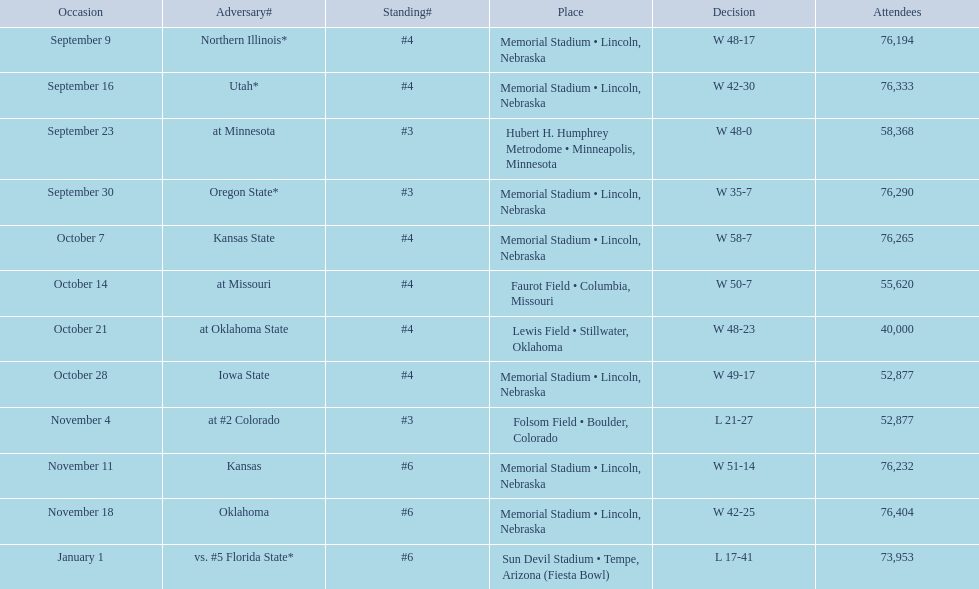What is the next site listed after lewis field? Memorial Stadium • Lincoln, Nebraska. 